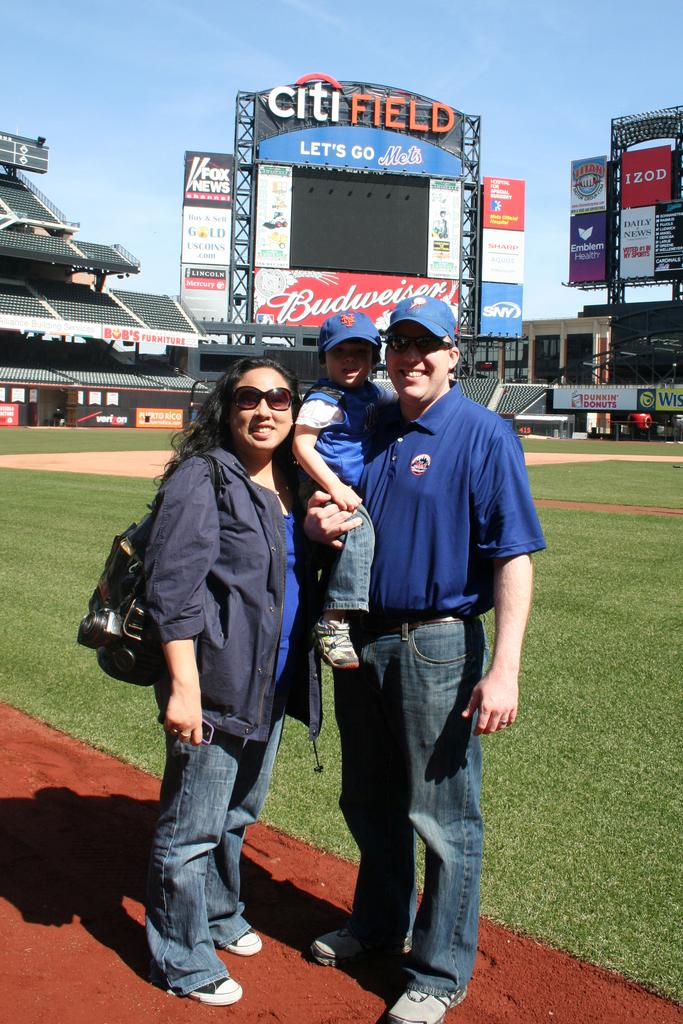Provide a one-sentence caption for the provided image. A couple and a child stand on the Citifield baseball field. 